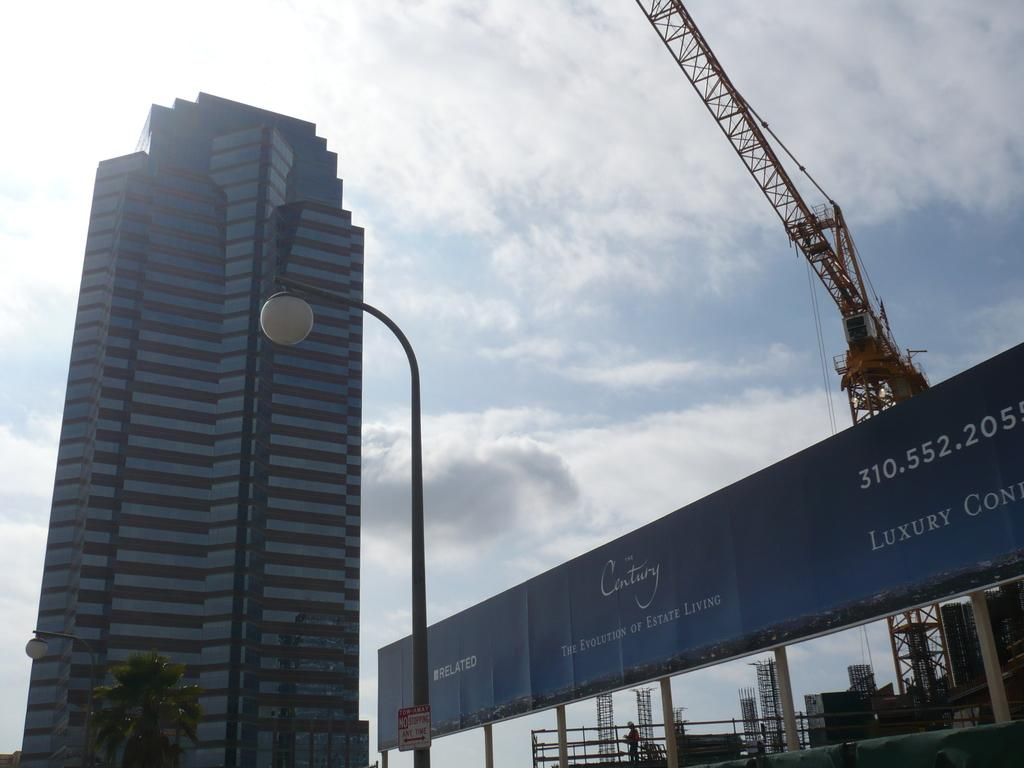What type of structures can be seen in the image? There are buildings and towers in the image. What material is used for the rods visible in the image? Metal rods are visible in the image. What type of vegetation is present in the image? There is a tree in the image. What is visible in the background of the image? The sky is visible in the image. Can you determine the time of day the image was taken? The image was likely taken during the day, as the sky is visible and not dark. What type of soap is being used to clean the beast in the image? There is no soap, beast, or cleaning activity present in the image. 